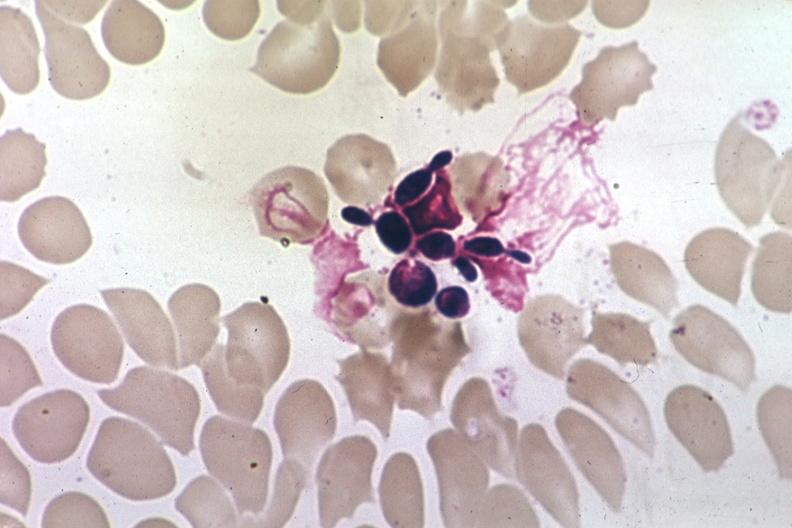what does this image show?
Answer the question using a single word or phrase. Wrights budding yeast forms 